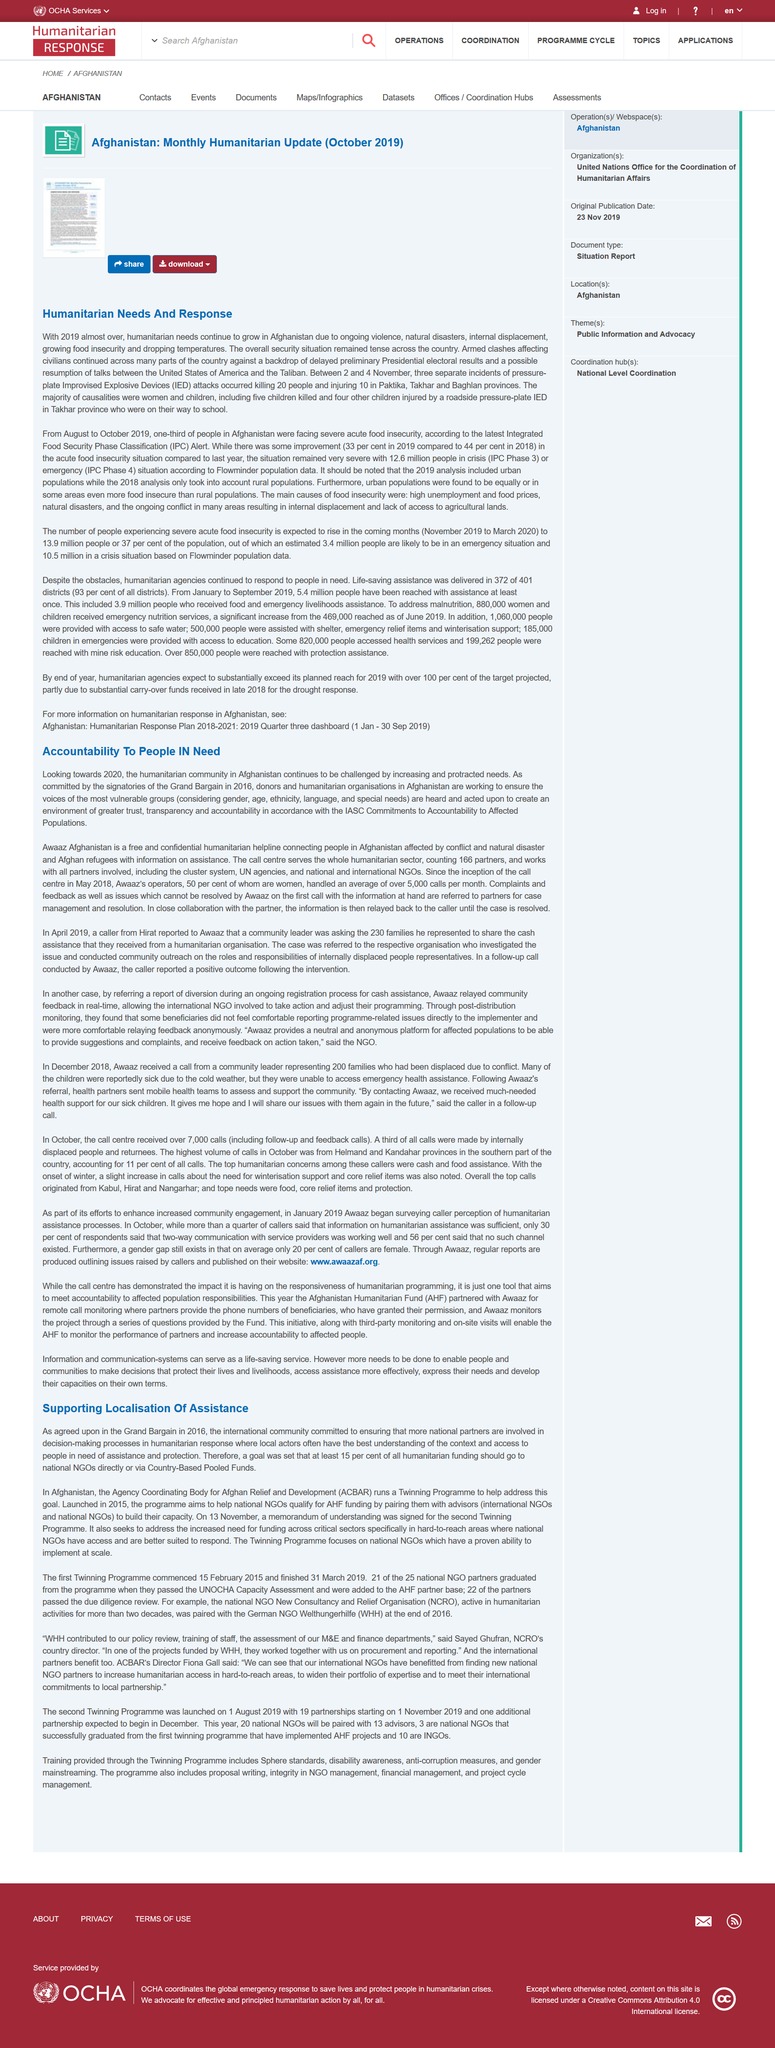List a handful of essential elements in this visual. The title of this section is 'Humanitarian Needs and Response,' declaring its purpose to provide comprehensive information on the critical issues and solutions facing the humanitarian aid sector. According to recent data, one-third of the population in Afghanistan was facing severe acute food insecurity, a critical situation that required urgent attention and intervention. The Integrated Food Security Phase Classification Alert and Improvised Explosive Devices attacks are full names for two distinct types of incidents. The Integrated Food Security Phase Classification Alert refers to a warning system used to track and monitor food insecurity in areas affected by crisis events, such as conflict or natural disasters. The Improvised Explosive Devices attacks, on the other hand, refer to incidents involving the use of homemade bombs or explosives to cause harm or destruction. 